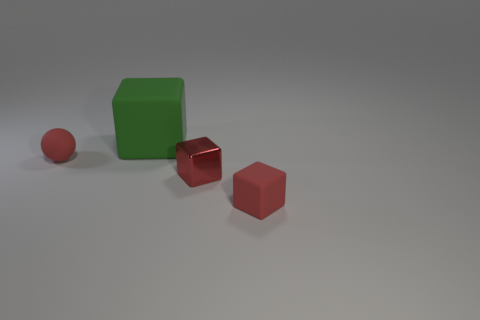Is there any other thing that is the same size as the green matte thing?
Provide a succinct answer. No. What number of things are large blue metallic things or metal cubes?
Ensure brevity in your answer.  1. The tiny metal cube is what color?
Your response must be concise. Red. What number of other objects are there of the same color as the metallic thing?
Your answer should be compact. 2. Are there any metallic objects behind the ball?
Give a very brief answer. No. What is the color of the rubber block in front of the tiny red cube that is left of the red rubber thing that is on the right side of the metal cube?
Your answer should be compact. Red. What number of small red objects are both behind the small red rubber cube and in front of the ball?
Offer a terse response. 1. How many cubes are red shiny objects or blue metal things?
Keep it short and to the point. 1. Are there any small metallic blocks?
Provide a short and direct response. Yes. There is another cube that is the same size as the red matte cube; what material is it?
Your answer should be very brief. Metal. 